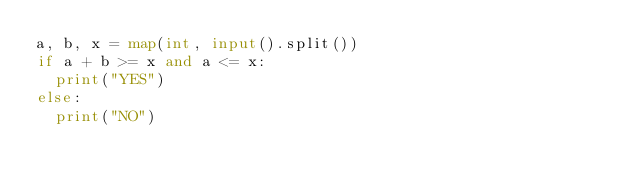Convert code to text. <code><loc_0><loc_0><loc_500><loc_500><_Python_>a, b, x = map(int, input().split())
if a + b >= x and a <= x:
  print("YES")
else:
  print("NO")
</code> 